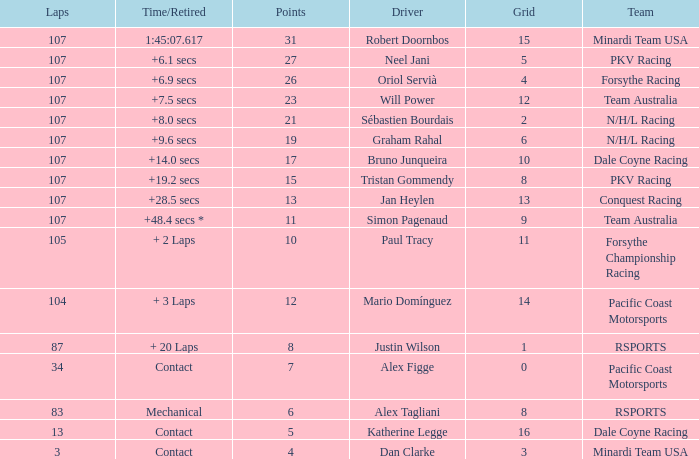What is mario domínguez's average Grid? 14.0. 